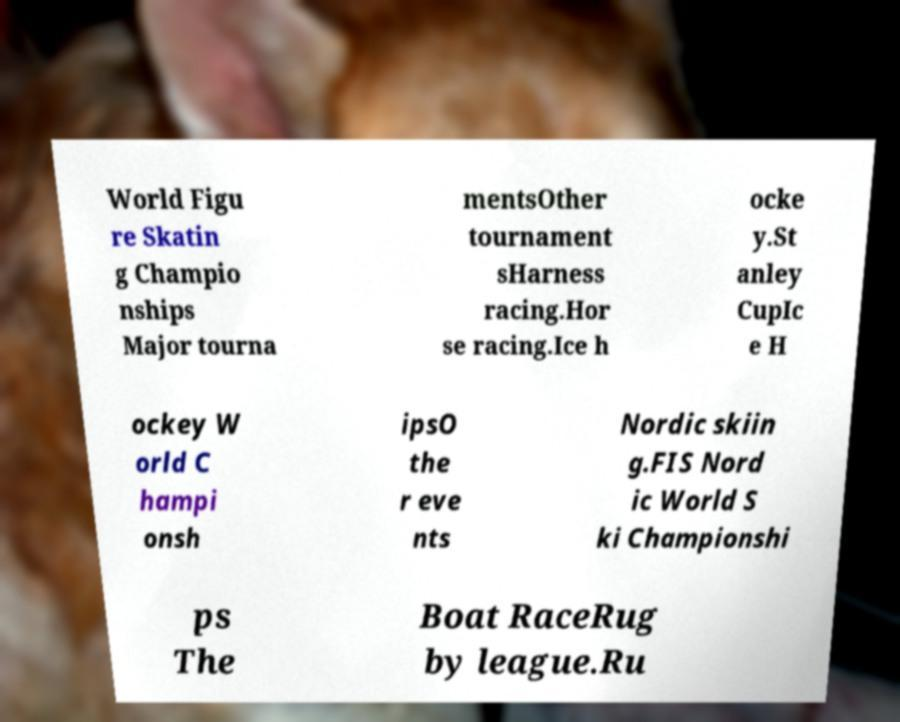For documentation purposes, I need the text within this image transcribed. Could you provide that? World Figu re Skatin g Champio nships Major tourna mentsOther tournament sHarness racing.Hor se racing.Ice h ocke y.St anley CupIc e H ockey W orld C hampi onsh ipsO the r eve nts Nordic skiin g.FIS Nord ic World S ki Championshi ps The Boat RaceRug by league.Ru 